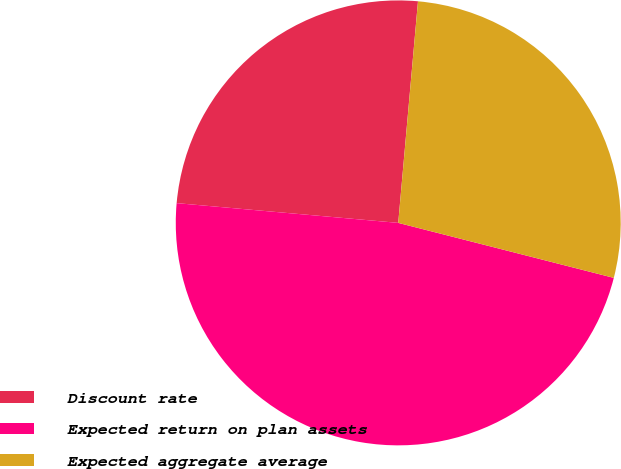<chart> <loc_0><loc_0><loc_500><loc_500><pie_chart><fcel>Discount rate<fcel>Expected return on plan assets<fcel>Expected aggregate average<nl><fcel>25.0%<fcel>47.44%<fcel>27.56%<nl></chart> 